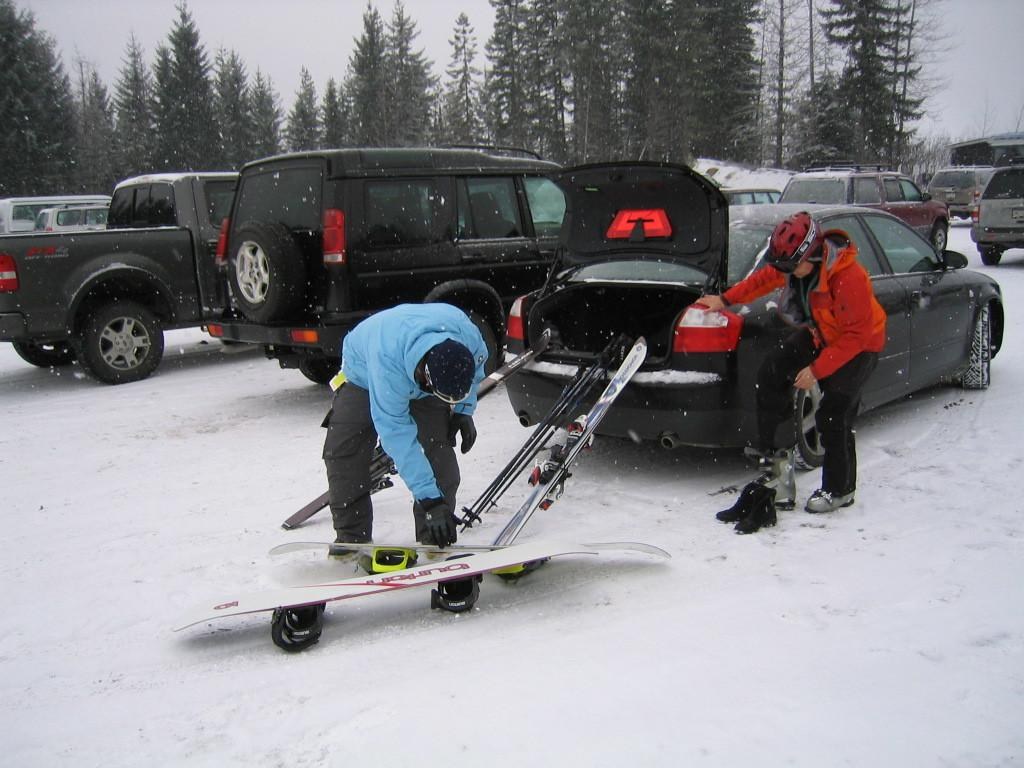How many people are in the image? There are two persons in the image. What is one person holding in the image? One person is holding a ski board. What else can be seen in the image besides the people? There are vehicles and trees in the image. What is the condition of the ground in the image? The ground is covered with snow. What direction are the dinosaurs facing in the image? There are no dinosaurs present in the image. Can you tell me what type of shop is visible in the image? There is no shop visible in the image. 